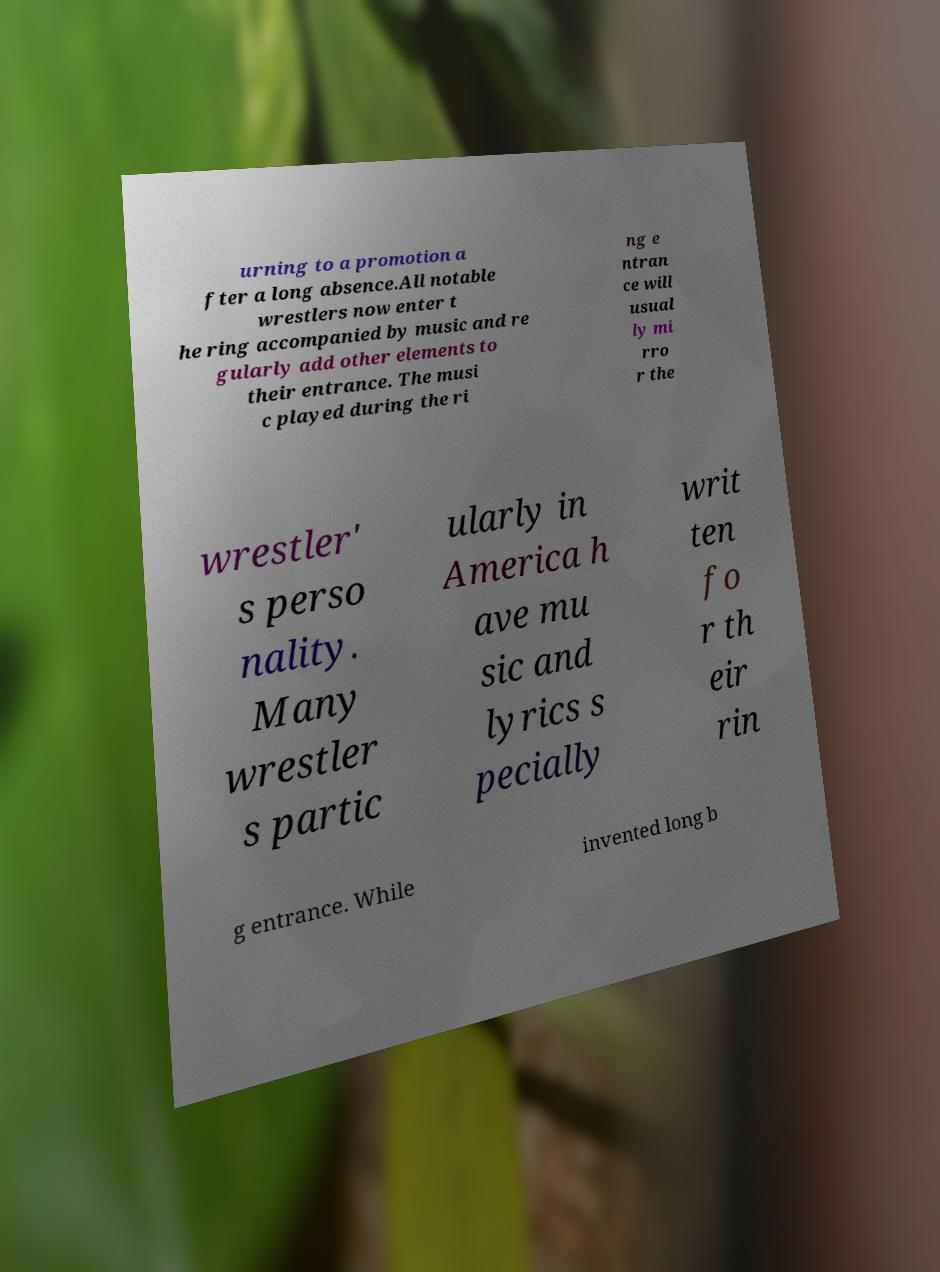Please identify and transcribe the text found in this image. urning to a promotion a fter a long absence.All notable wrestlers now enter t he ring accompanied by music and re gularly add other elements to their entrance. The musi c played during the ri ng e ntran ce will usual ly mi rro r the wrestler' s perso nality. Many wrestler s partic ularly in America h ave mu sic and lyrics s pecially writ ten fo r th eir rin g entrance. While invented long b 